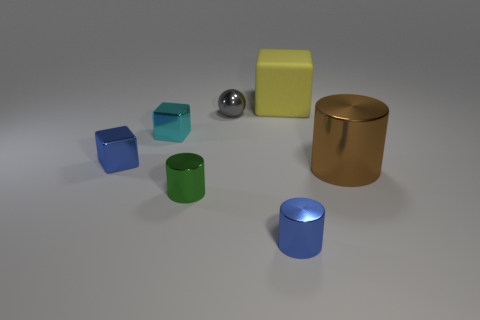Do the green object and the blue cylinder have the same size?
Ensure brevity in your answer.  Yes. There is a big thing that is to the left of the brown metal cylinder that is right of the small cube left of the cyan shiny object; what is its color?
Offer a terse response. Yellow. What number of cylinders have the same color as the large cube?
Your answer should be compact. 0. What number of big objects are brown balls or blue shiny cylinders?
Make the answer very short. 0. Are there any big yellow things that have the same shape as the cyan metal thing?
Provide a short and direct response. Yes. Do the big brown shiny object and the cyan metal object have the same shape?
Give a very brief answer. No. What color is the shiny cylinder to the right of the tiny blue metallic object that is to the right of the small blue shiny cube?
Provide a short and direct response. Brown. What color is the other cube that is the same size as the cyan shiny block?
Offer a very short reply. Blue. How many matte objects are either gray balls or tiny cyan blocks?
Your response must be concise. 0. There is a large brown cylinder that is behind the tiny green shiny object; how many big brown metal objects are behind it?
Your answer should be compact. 0. 